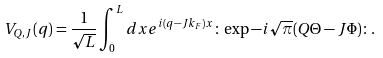<formula> <loc_0><loc_0><loc_500><loc_500>V _ { Q , J } ( q ) = \frac { 1 } { \sqrt { L } } \int _ { 0 } ^ { L } d x e ^ { i ( q - J k _ { F } ) x } \colon \exp - i \sqrt { \pi } ( Q \Theta - J \Phi ) \colon .</formula> 